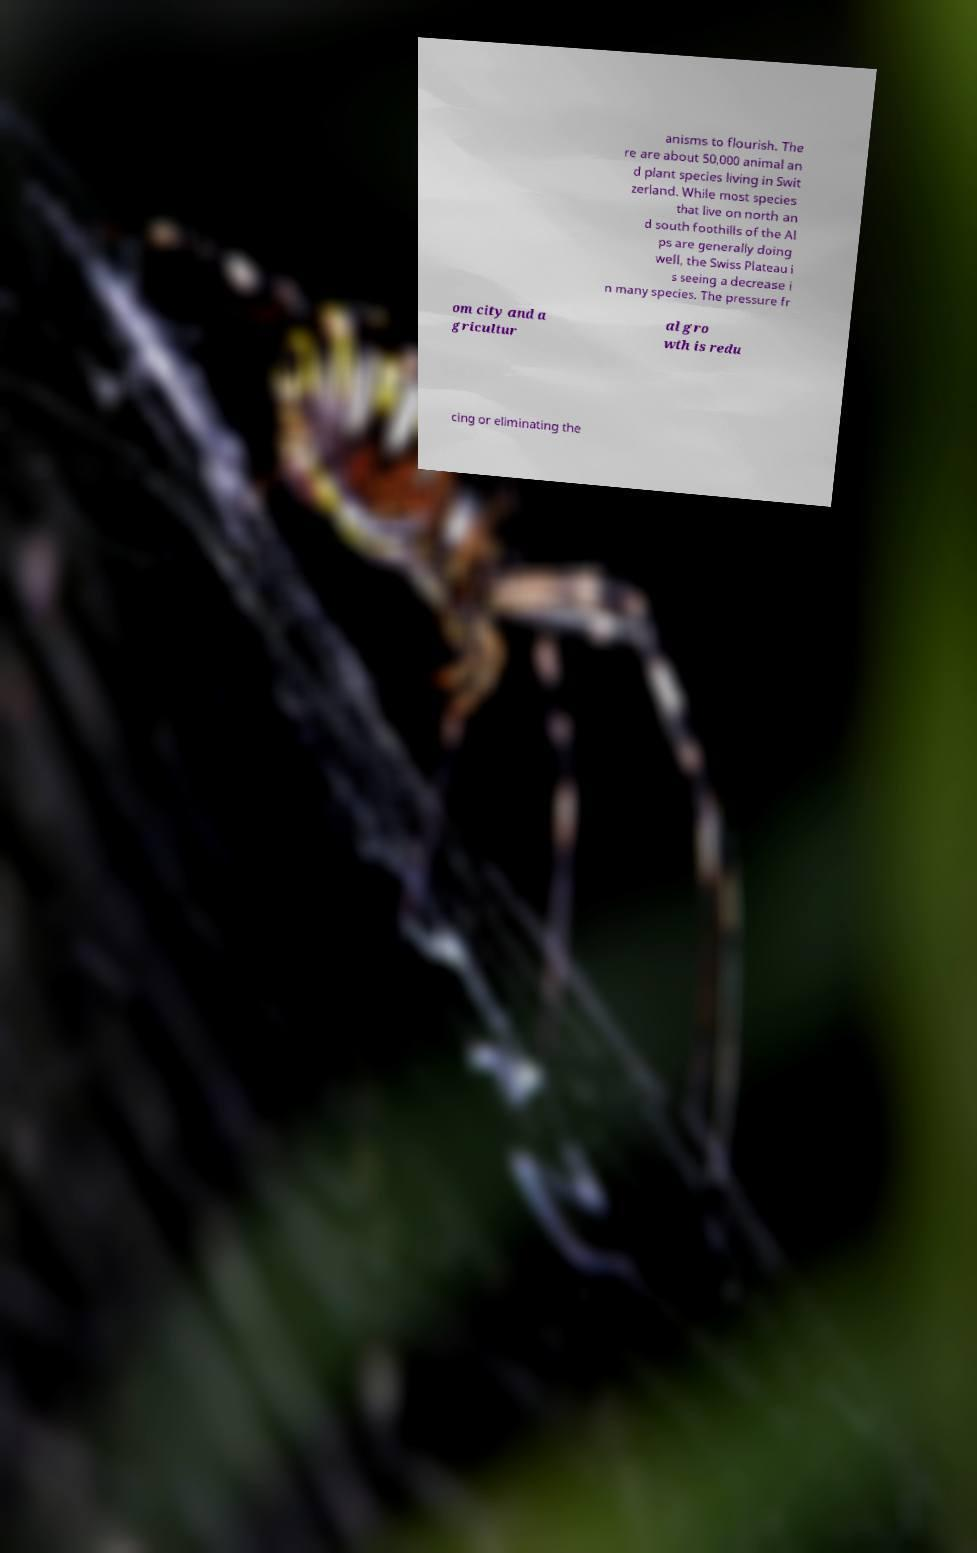Please read and relay the text visible in this image. What does it say? anisms to flourish. The re are about 50,000 animal an d plant species living in Swit zerland. While most species that live on north an d south foothills of the Al ps are generally doing well, the Swiss Plateau i s seeing a decrease i n many species. The pressure fr om city and a gricultur al gro wth is redu cing or eliminating the 